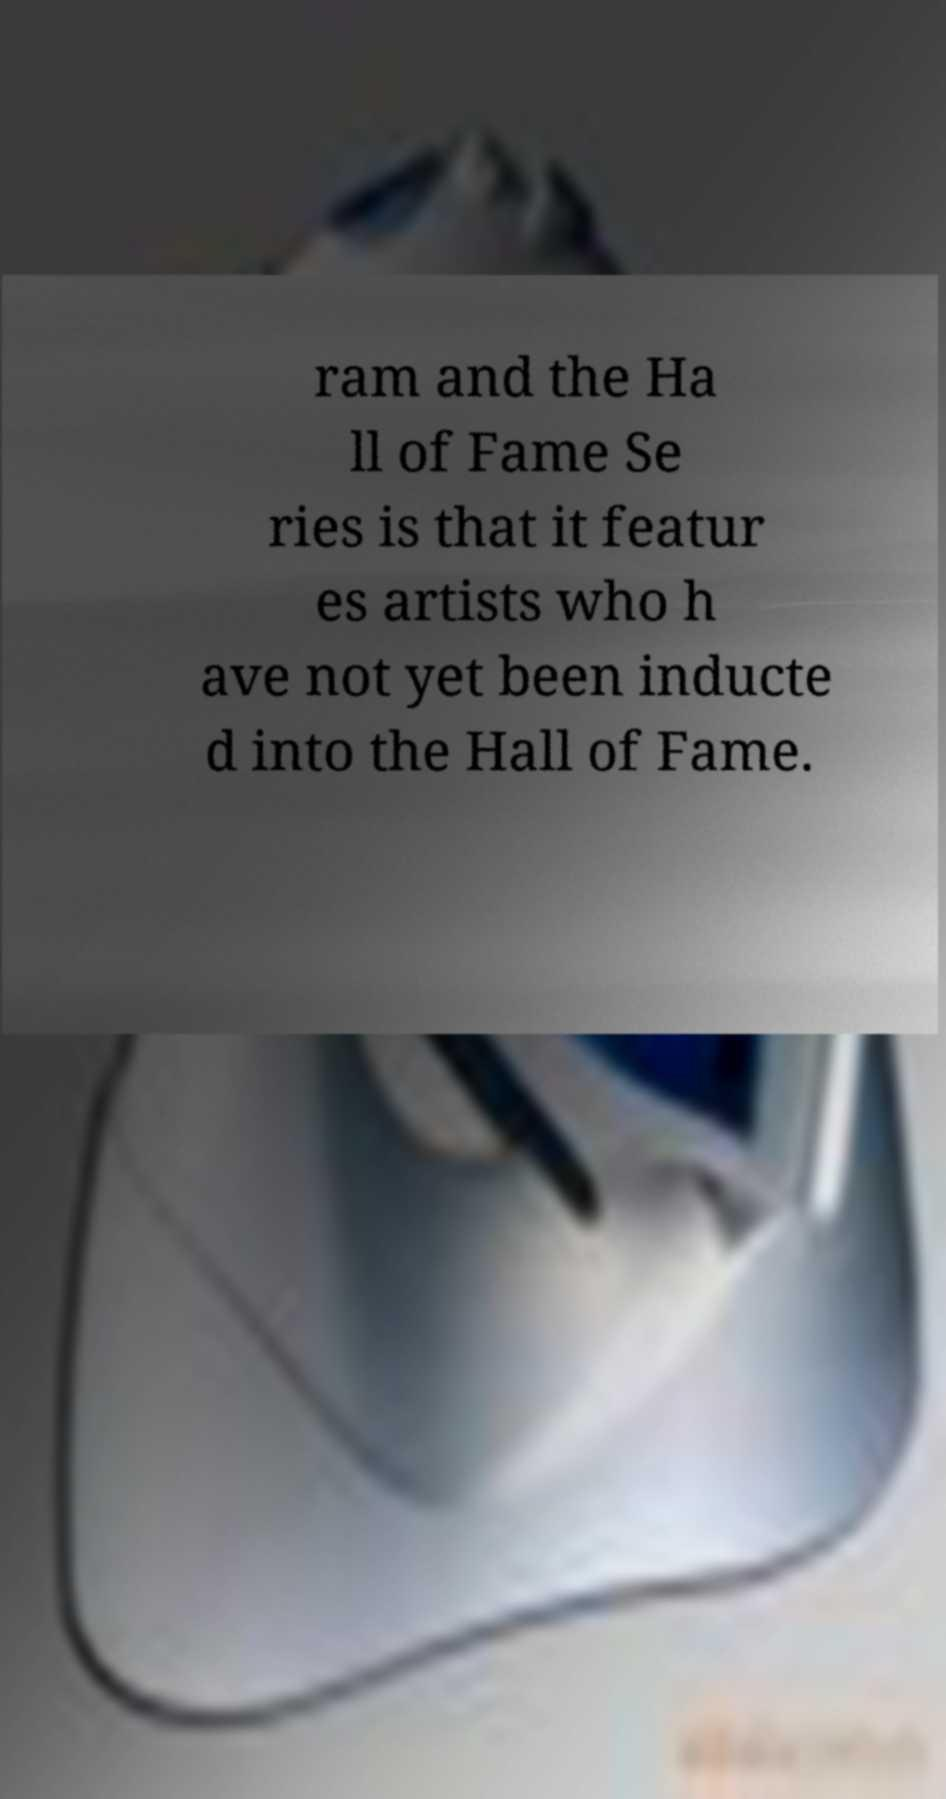There's text embedded in this image that I need extracted. Can you transcribe it verbatim? ram and the Ha ll of Fame Se ries is that it featur es artists who h ave not yet been inducte d into the Hall of Fame. 